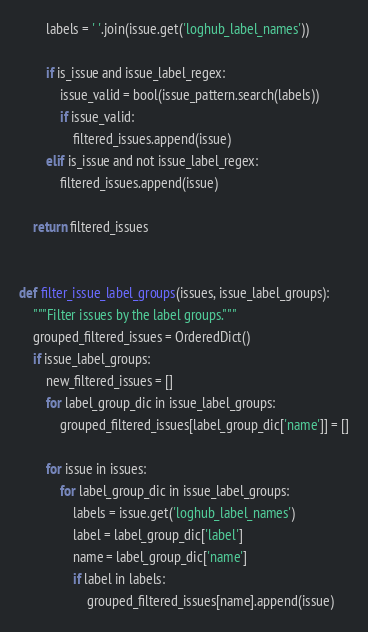Convert code to text. <code><loc_0><loc_0><loc_500><loc_500><_Python_>        labels = ' '.join(issue.get('loghub_label_names'))

        if is_issue and issue_label_regex:
            issue_valid = bool(issue_pattern.search(labels))
            if issue_valid:
                filtered_issues.append(issue)
        elif is_issue and not issue_label_regex:
            filtered_issues.append(issue)

    return filtered_issues


def filter_issue_label_groups(issues, issue_label_groups):
    """Filter issues by the label groups."""
    grouped_filtered_issues = OrderedDict()
    if issue_label_groups:
        new_filtered_issues = []
        for label_group_dic in issue_label_groups:
            grouped_filtered_issues[label_group_dic['name']] = []

        for issue in issues:
            for label_group_dic in issue_label_groups:
                labels = issue.get('loghub_label_names')
                label = label_group_dic['label']
                name = label_group_dic['name']
                if label in labels:
                    grouped_filtered_issues[name].append(issue)</code> 